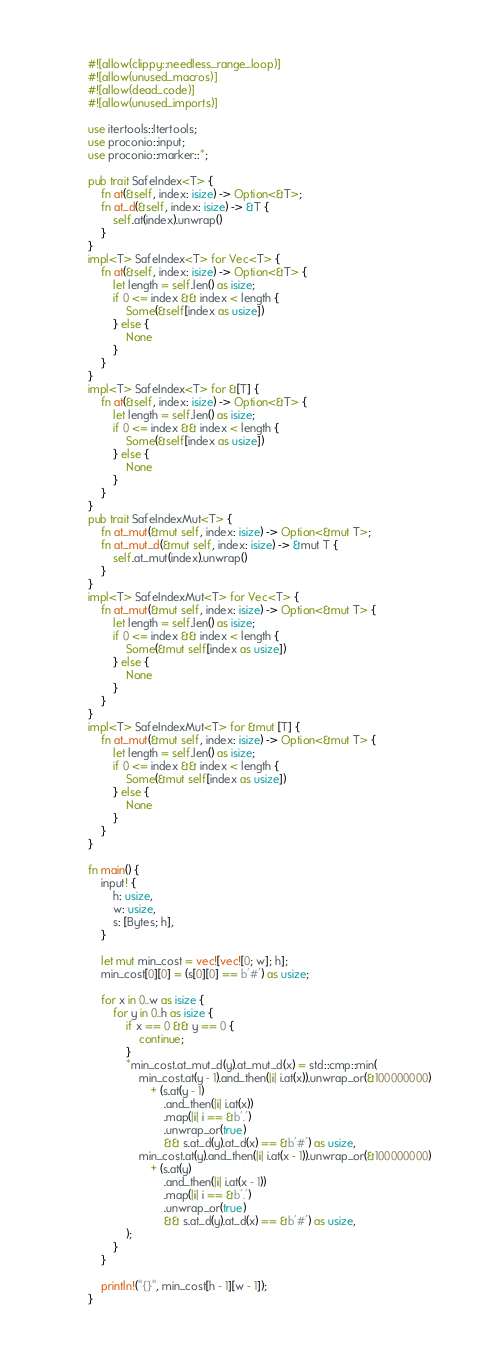<code> <loc_0><loc_0><loc_500><loc_500><_Rust_>#![allow(clippy::needless_range_loop)]
#![allow(unused_macros)]
#![allow(dead_code)]
#![allow(unused_imports)]

use itertools::Itertools;
use proconio::input;
use proconio::marker::*;

pub trait SafeIndex<T> {
    fn at(&self, index: isize) -> Option<&T>;
    fn at_d(&self, index: isize) -> &T {
        self.at(index).unwrap()
    }
}
impl<T> SafeIndex<T> for Vec<T> {
    fn at(&self, index: isize) -> Option<&T> {
        let length = self.len() as isize;
        if 0 <= index && index < length {
            Some(&self[index as usize])
        } else {
            None
        }
    }
}
impl<T> SafeIndex<T> for &[T] {
    fn at(&self, index: isize) -> Option<&T> {
        let length = self.len() as isize;
        if 0 <= index && index < length {
            Some(&self[index as usize])
        } else {
            None
        }
    }
}
pub trait SafeIndexMut<T> {
    fn at_mut(&mut self, index: isize) -> Option<&mut T>;
    fn at_mut_d(&mut self, index: isize) -> &mut T {
        self.at_mut(index).unwrap()
    }
}
impl<T> SafeIndexMut<T> for Vec<T> {
    fn at_mut(&mut self, index: isize) -> Option<&mut T> {
        let length = self.len() as isize;
        if 0 <= index && index < length {
            Some(&mut self[index as usize])
        } else {
            None
        }
    }
}
impl<T> SafeIndexMut<T> for &mut [T] {
    fn at_mut(&mut self, index: isize) -> Option<&mut T> {
        let length = self.len() as isize;
        if 0 <= index && index < length {
            Some(&mut self[index as usize])
        } else {
            None
        }
    }
}

fn main() {
    input! {
        h: usize,
        w: usize,
        s: [Bytes; h],
    }

    let mut min_cost = vec![vec![0; w]; h];
    min_cost[0][0] = (s[0][0] == b'#') as usize;

    for x in 0..w as isize {
        for y in 0..h as isize {
            if x == 0 && y == 0 {
                continue;
            }
            *min_cost.at_mut_d(y).at_mut_d(x) = std::cmp::min(
                min_cost.at(y - 1).and_then(|i| i.at(x)).unwrap_or(&100000000)
                    + (s.at(y - 1)
                        .and_then(|i| i.at(x))
                        .map(|i| i == &b'.')
                        .unwrap_or(true)
                        && s.at_d(y).at_d(x) == &b'#') as usize,
                min_cost.at(y).and_then(|i| i.at(x - 1)).unwrap_or(&100000000)
                    + (s.at(y)
                        .and_then(|i| i.at(x - 1))
                        .map(|i| i == &b'.')
                        .unwrap_or(true)
                        && s.at_d(y).at_d(x) == &b'#') as usize,
            );
        }
    }

    println!("{}", min_cost[h - 1][w - 1]);
}
</code> 